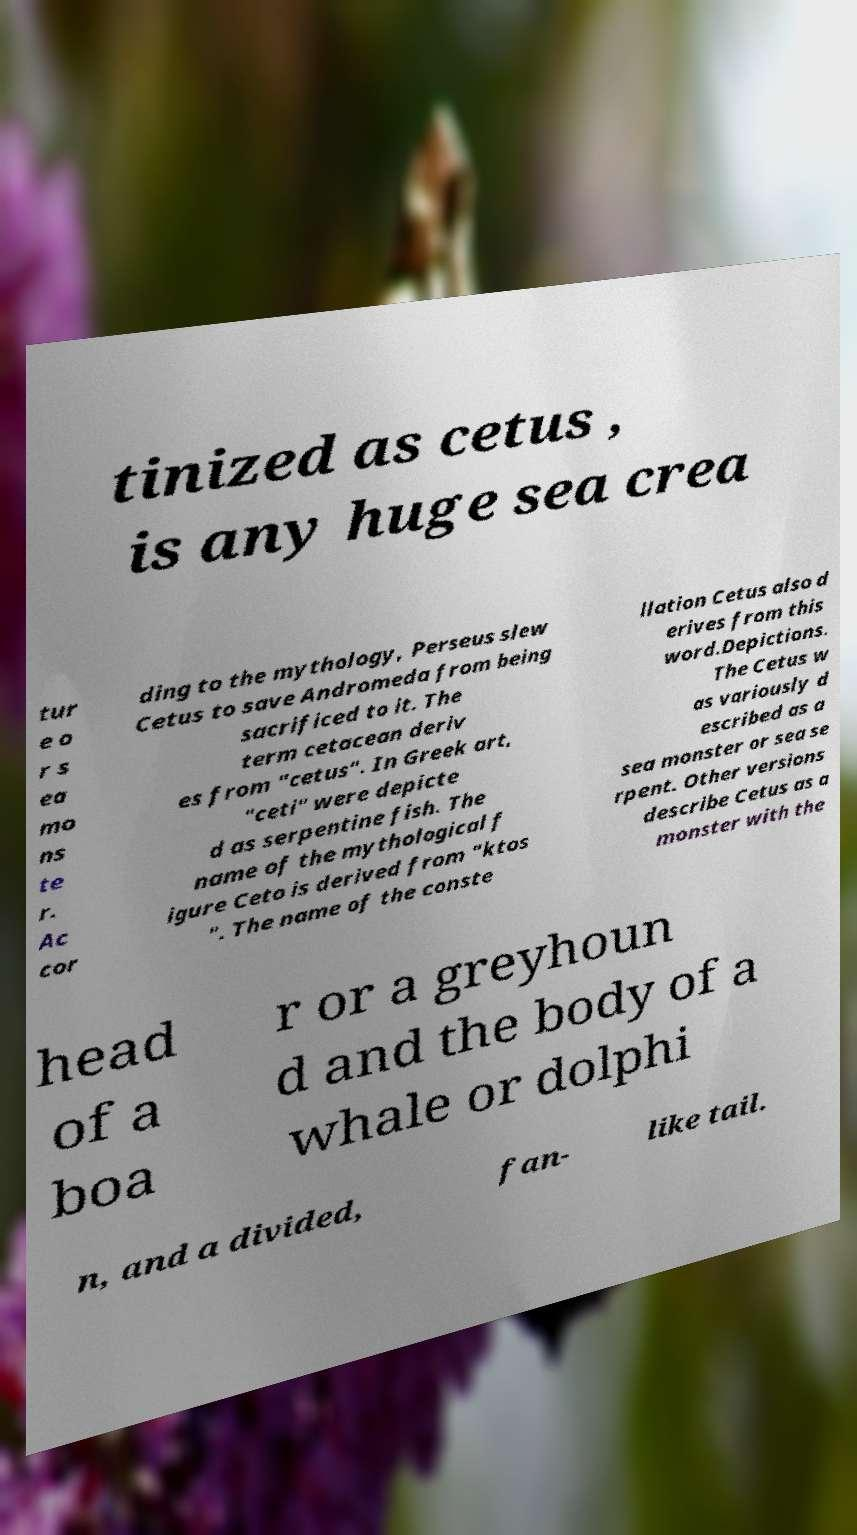Could you extract and type out the text from this image? tinized as cetus , is any huge sea crea tur e o r s ea mo ns te r. Ac cor ding to the mythology, Perseus slew Cetus to save Andromeda from being sacrificed to it. The term cetacean deriv es from "cetus". In Greek art, "ceti" were depicte d as serpentine fish. The name of the mythological f igure Ceto is derived from "ktos ". The name of the conste llation Cetus also d erives from this word.Depictions. The Cetus w as variously d escribed as a sea monster or sea se rpent. Other versions describe Cetus as a monster with the head of a boa r or a greyhoun d and the body of a whale or dolphi n, and a divided, fan- like tail. 